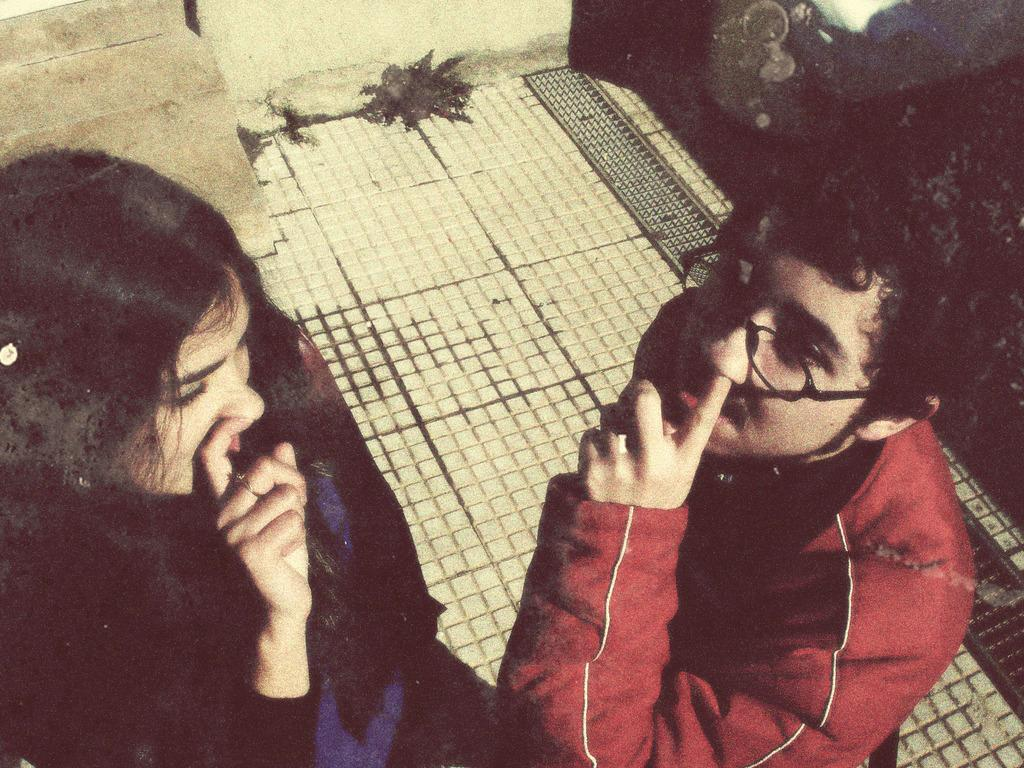How many people are in the image? There are two people in the image, a man and a woman. What is the man wearing in the image? The man is wearing spectacles in the image. What is the woman wearing in the image? The woman is wearing a dress in the image. What type of plate is being used to push the man in the image? There is no plate or pushing action present in the image. 